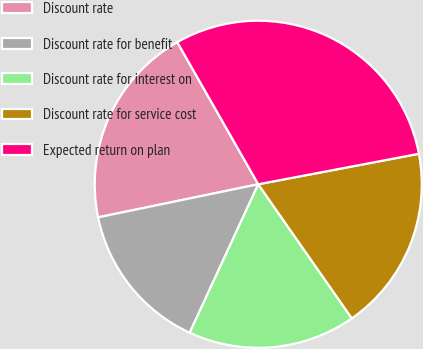Convert chart. <chart><loc_0><loc_0><loc_500><loc_500><pie_chart><fcel>Discount rate<fcel>Discount rate for benefit<fcel>Discount rate for interest on<fcel>Discount rate for service cost<fcel>Expected return on plan<nl><fcel>20.0%<fcel>14.87%<fcel>16.58%<fcel>18.29%<fcel>30.26%<nl></chart> 